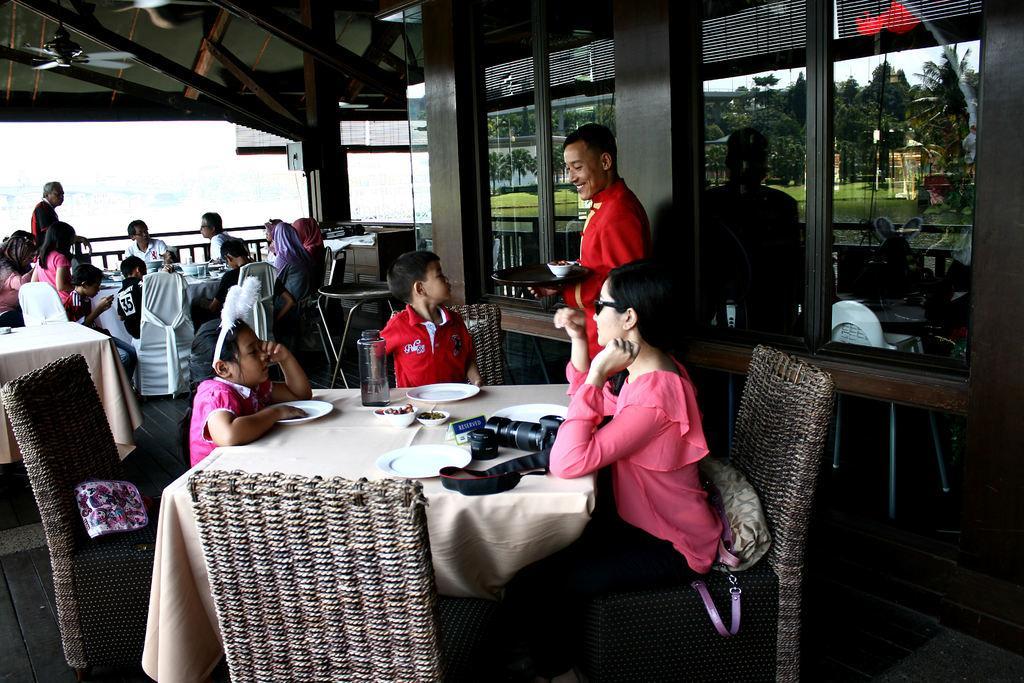How would you summarize this image in a sentence or two? In this picture we can see two persons standing. We can see few persons sitting on chairs in front of a table and on the table we can see camera, plates, bowl, bottles. These are windows. Here we can see the reflection of trees and green grass. 